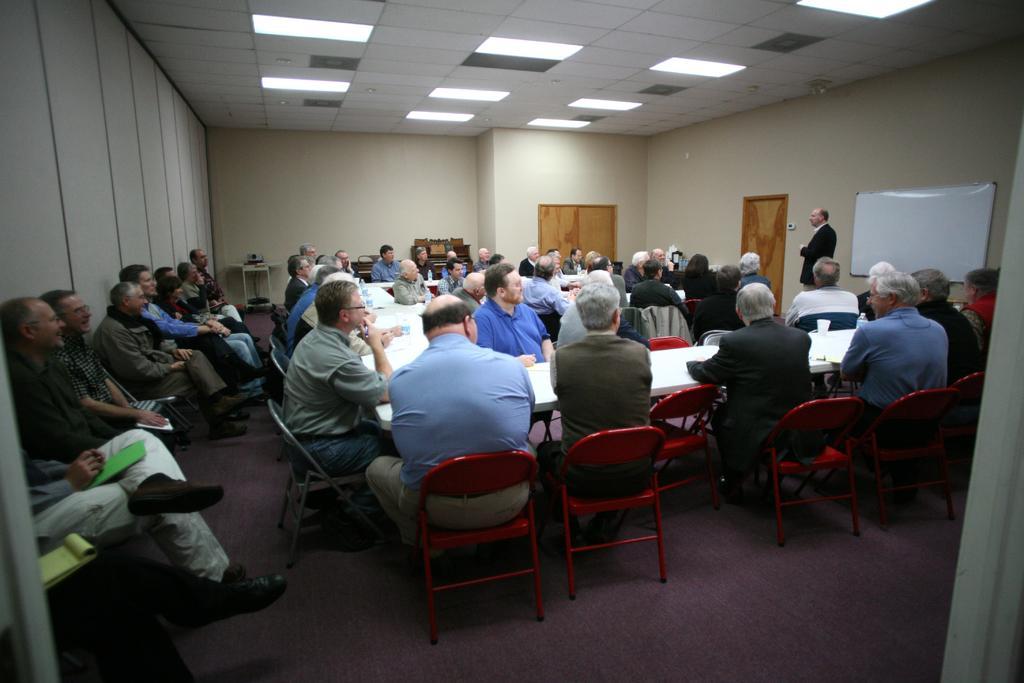How would you summarize this image in a sentence or two? in a room there are white tables and people are seated around the tables on the red and grey chairs. at the left, in a line there are other people sitting. at the left there is a white board on the wall and a person is standing in front of it wearing black suit. there are 2 wooden doors on the wall. on the top there are many lights. all the people to the person standing at the right. 